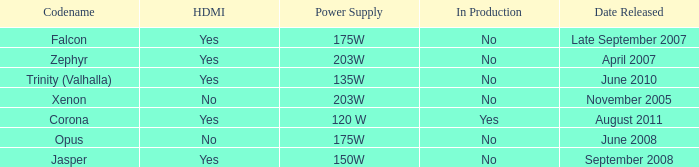Is Jasper being producted? No. 